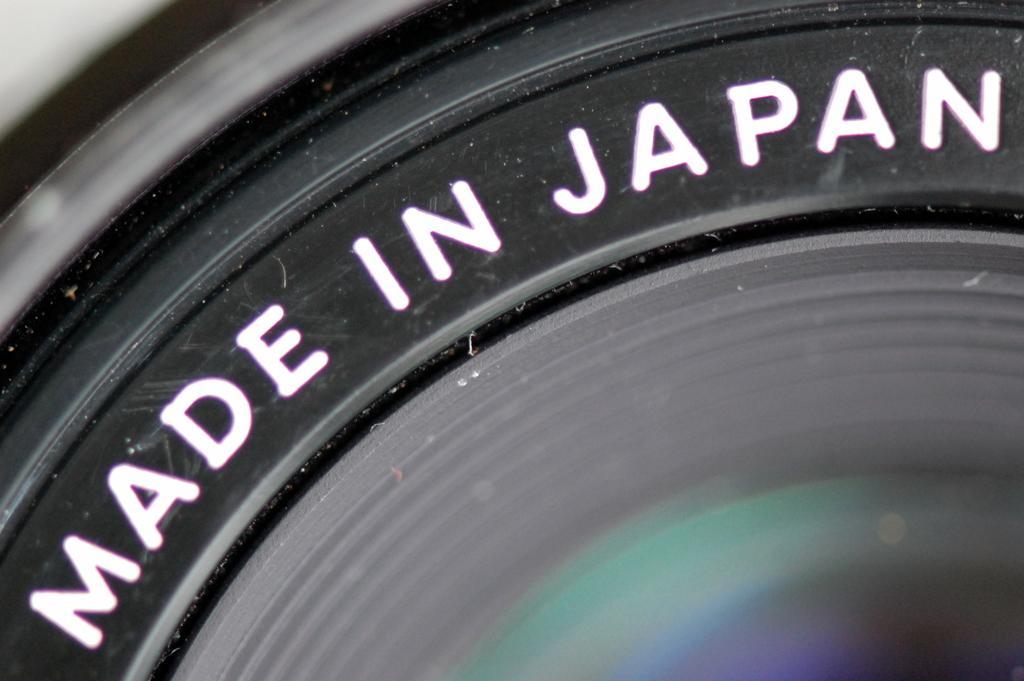Could you give a brief overview of what you see in this image? In this picture I can see the lens of a camera, there are words on the camera. 